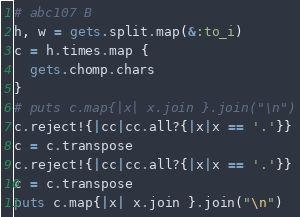Convert code to text. <code><loc_0><loc_0><loc_500><loc_500><_Ruby_># abc107 B
h, w = gets.split.map(&:to_i)
c = h.times.map {
  gets.chomp.chars
}
# puts c.map{|x| x.join }.join("\n")
c.reject!{|cc|cc.all?{|x|x == '.'}}
c = c.transpose
c.reject!{|cc|cc.all?{|x|x == '.'}}
c = c.transpose
puts c.map{|x| x.join }.join("\n")
</code> 